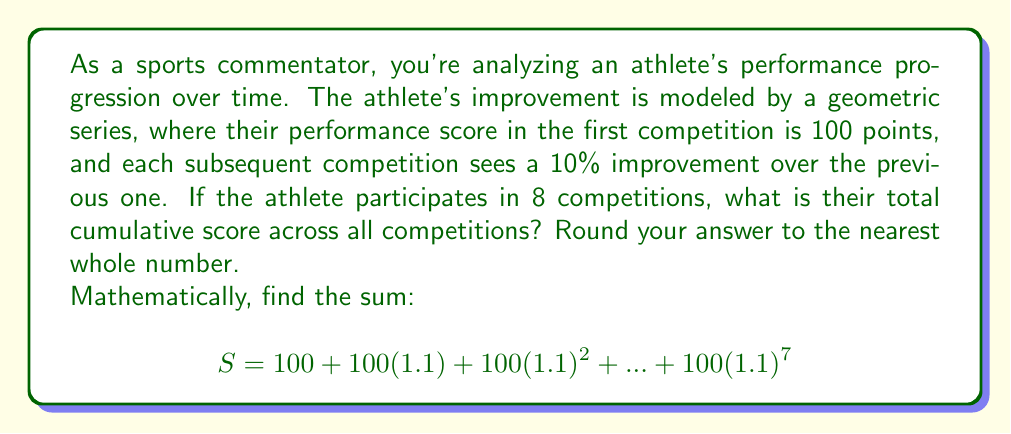Solve this math problem. Let's approach this step-by-step:

1) This is a geometric series with:
   - First term $a = 100$
   - Common ratio $r = 1.1$
   - Number of terms $n = 8$

2) The formula for the sum of a geometric series is:

   $$ S = \frac{a(1-r^n)}{1-r} $$

   where $a$ is the first term, $r$ is the common ratio, and $n$ is the number of terms.

3) Substituting our values:

   $$ S = \frac{100(1-1.1^8)}{1-1.1} $$

4) Let's calculate $1.1^8$:
   $1.1^8 \approx 2.14358881$

5) Now we can compute:

   $$ S = \frac{100(1-2.14358881)}{1-1.1} = \frac{100(-1.14358881)}{-0.1} $$

6) Simplifying:

   $$ S = 1143.58881 $$

7) Rounding to the nearest whole number:

   $S \approx 1144$

This progression demonstrates the power of consistent improvement, reinforcing the importance of mental strength and perseverance in an athlete's journey.
Answer: 1144 points 